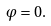Convert formula to latex. <formula><loc_0><loc_0><loc_500><loc_500>\varphi = 0 .</formula> 